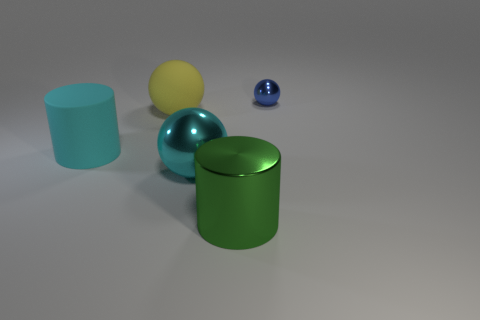Subtract all big cyan balls. How many balls are left? 2 Add 1 tiny blue shiny spheres. How many objects exist? 6 Subtract all spheres. How many objects are left? 2 Subtract all brown balls. Subtract all purple blocks. How many balls are left? 3 Subtract 1 green cylinders. How many objects are left? 4 Subtract all cyan spheres. Subtract all big cyan shiny spheres. How many objects are left? 3 Add 3 blue metallic things. How many blue metallic things are left? 4 Add 1 cyan metal things. How many cyan metal things exist? 2 